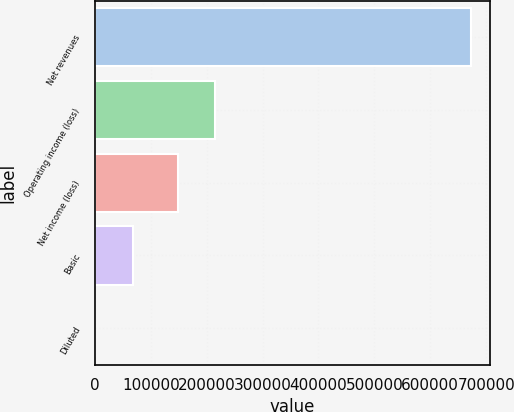Convert chart to OTSL. <chart><loc_0><loc_0><loc_500><loc_500><bar_chart><fcel>Net revenues<fcel>Operating income (loss)<fcel>Net income (loss)<fcel>Basic<fcel>Diluted<nl><fcel>673501<fcel>215266<fcel>147916<fcel>67350.5<fcel>0.43<nl></chart> 